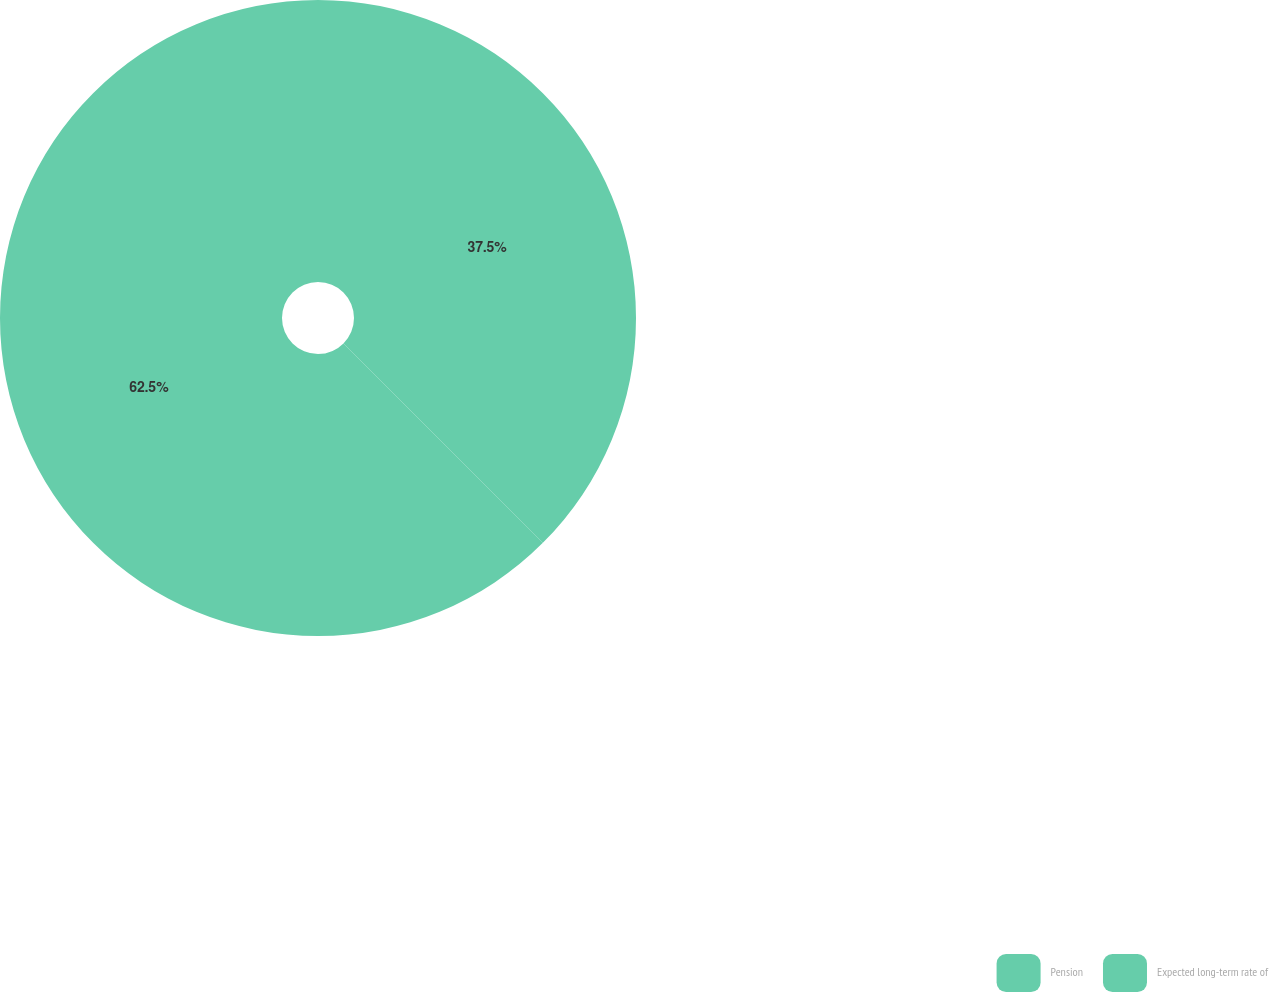<chart> <loc_0><loc_0><loc_500><loc_500><pie_chart><fcel>Pension<fcel>Expected long-term rate of<nl><fcel>37.5%<fcel>62.5%<nl></chart> 